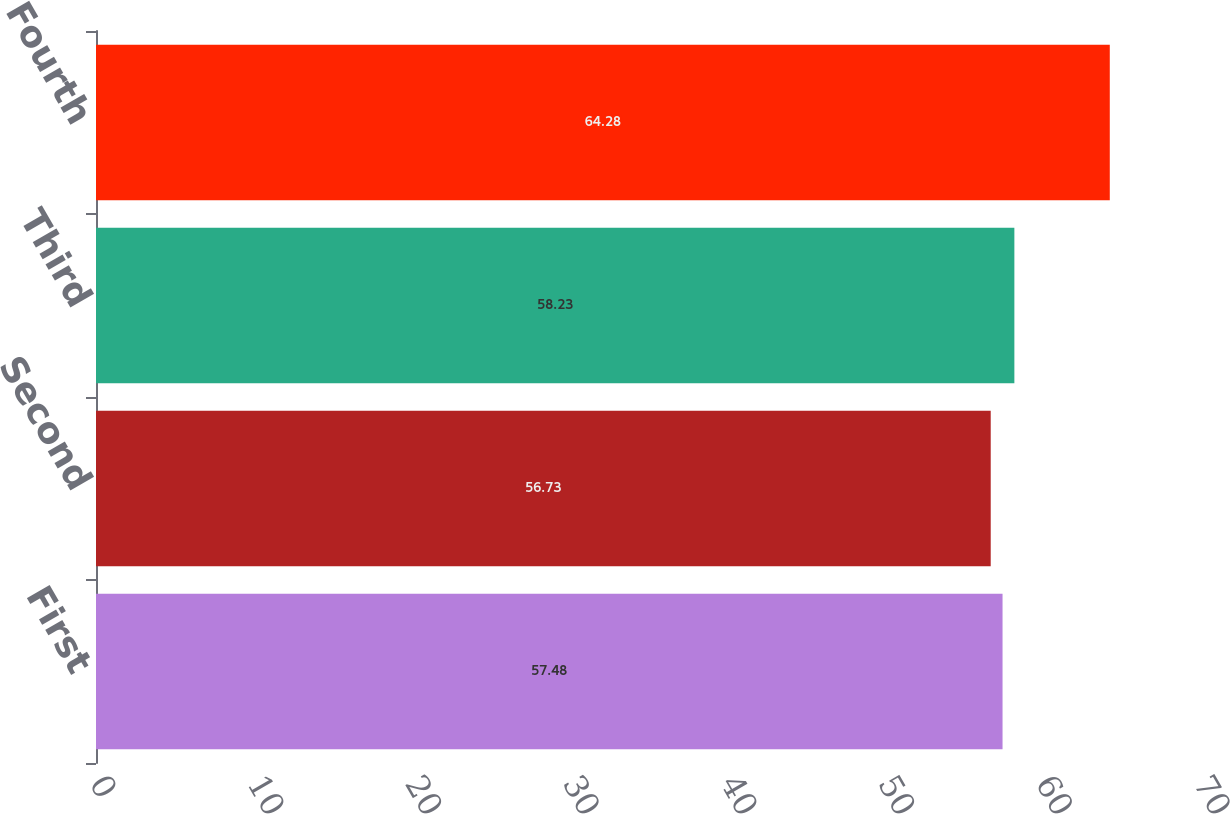Convert chart. <chart><loc_0><loc_0><loc_500><loc_500><bar_chart><fcel>First<fcel>Second<fcel>Third<fcel>Fourth<nl><fcel>57.48<fcel>56.73<fcel>58.23<fcel>64.28<nl></chart> 